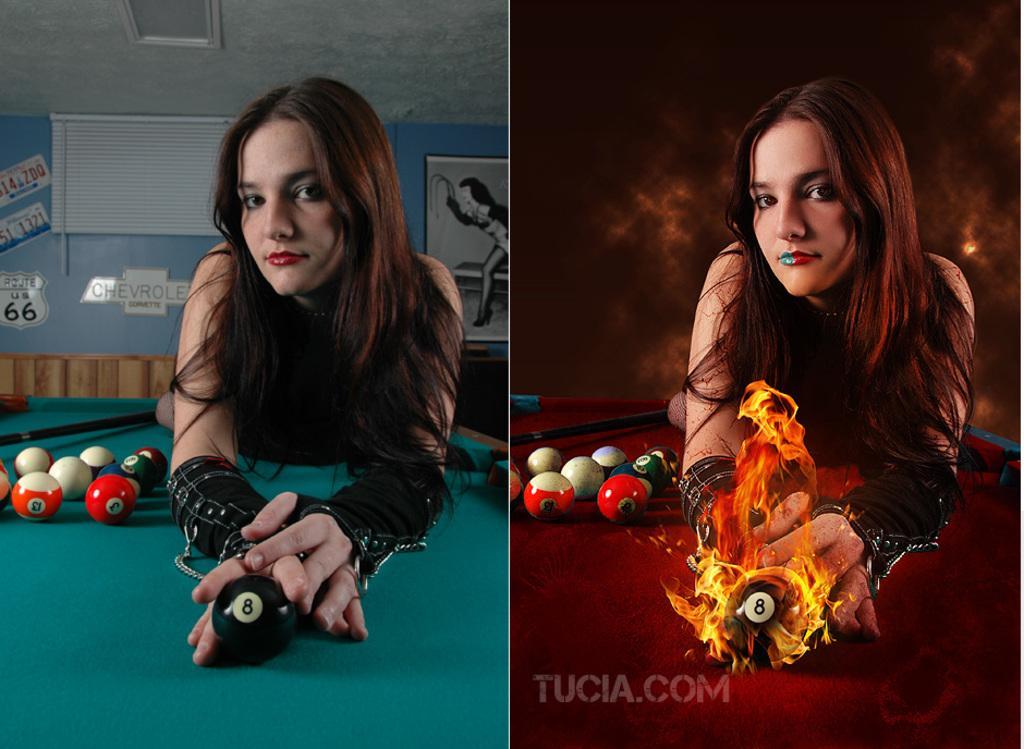Please provide a concise description of this image. In this picture we can see woman leaning on a snooker table and bedside to her we can see balls and in the background we can see wall, frames beside to this picture we have another picture same but with some graphical effects. 